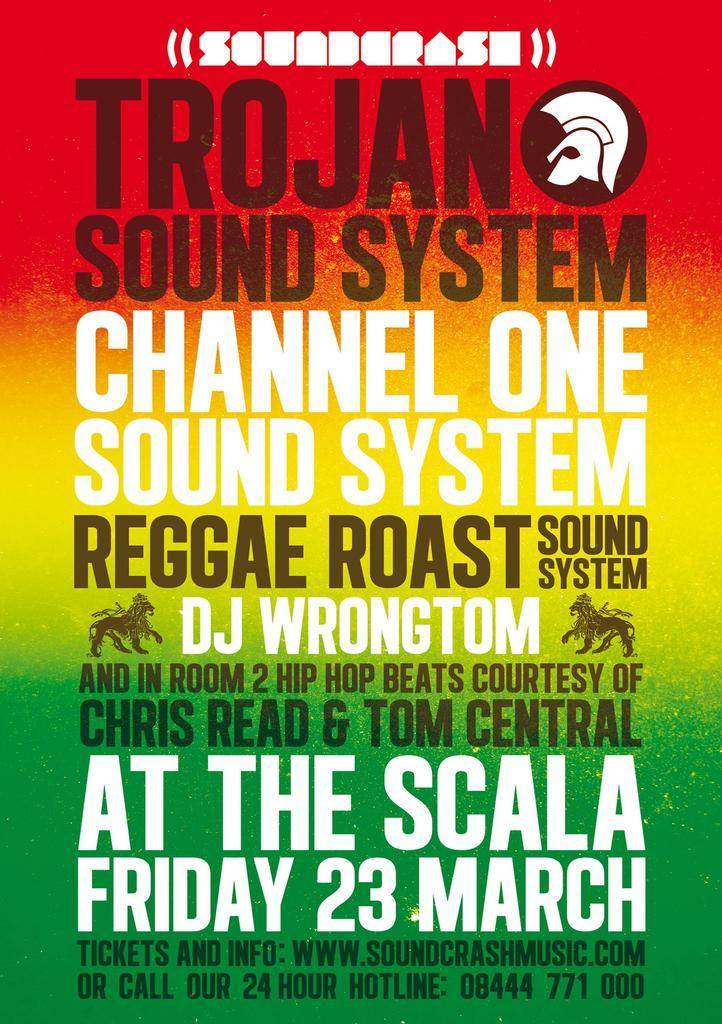<image>
Write a terse but informative summary of the picture. A poster for a music festival called Trojan Sound System. 